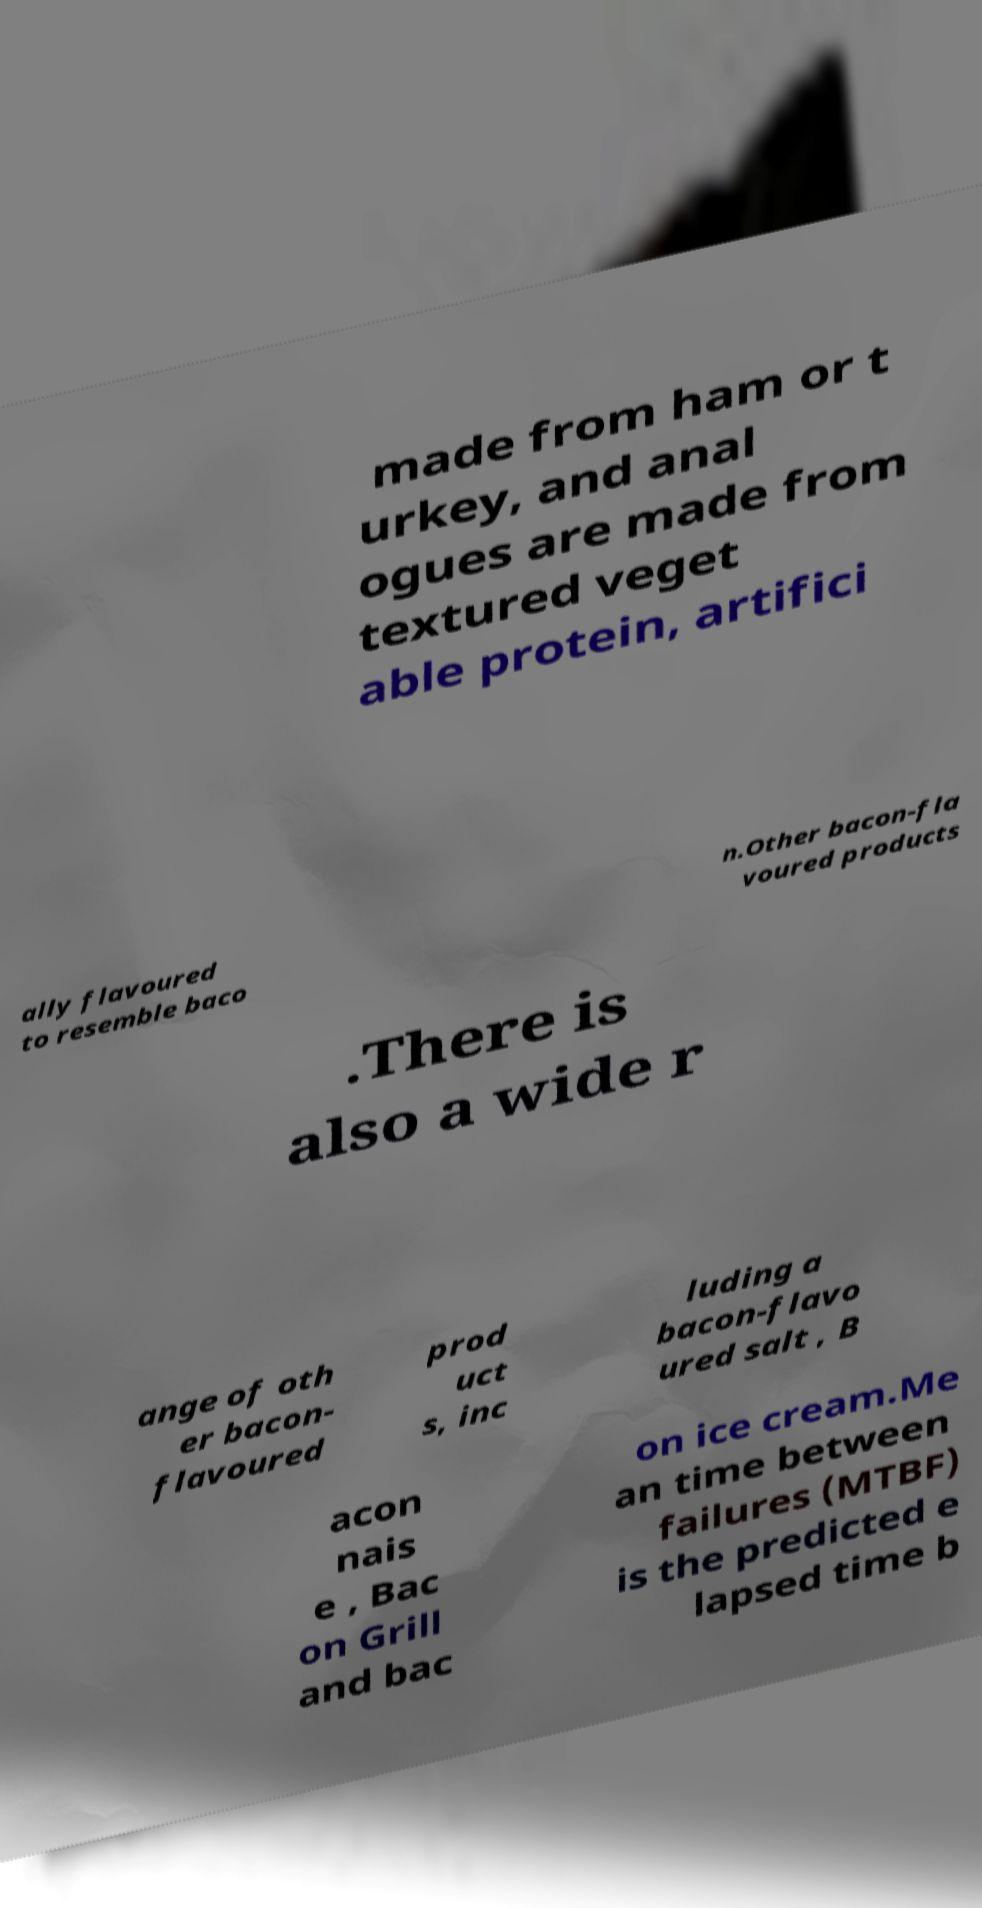What messages or text are displayed in this image? I need them in a readable, typed format. made from ham or t urkey, and anal ogues are made from textured veget able protein, artifici ally flavoured to resemble baco n.Other bacon-fla voured products .There is also a wide r ange of oth er bacon- flavoured prod uct s, inc luding a bacon-flavo ured salt , B acon nais e , Bac on Grill and bac on ice cream.Me an time between failures (MTBF) is the predicted e lapsed time b 